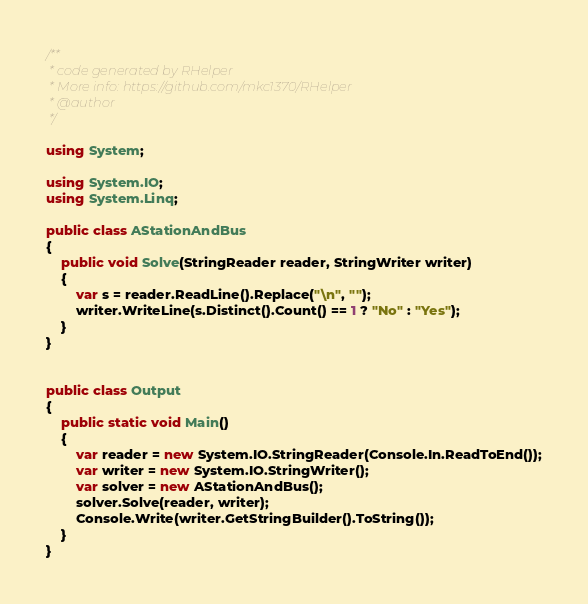<code> <loc_0><loc_0><loc_500><loc_500><_C#_>/**
 * code generated by RHelper
 * More info: https://github.com/mkc1370/RHelper
 * @author 
 */

using System;

using System.IO;
using System.Linq;

public class AStationAndBus
{
    public void Solve(StringReader reader, StringWriter writer)
    {
        var s = reader.ReadLine().Replace("\n", "");
        writer.WriteLine(s.Distinct().Count() == 1 ? "No" : "Yes");
    }
}


public class Output
{
	public static void Main()
	{
		var reader = new System.IO.StringReader(Console.In.ReadToEnd());
		var writer = new System.IO.StringWriter();
		var solver = new AStationAndBus();
		solver.Solve(reader, writer);
        Console.Write(writer.GetStringBuilder().ToString());
	}
}
</code> 